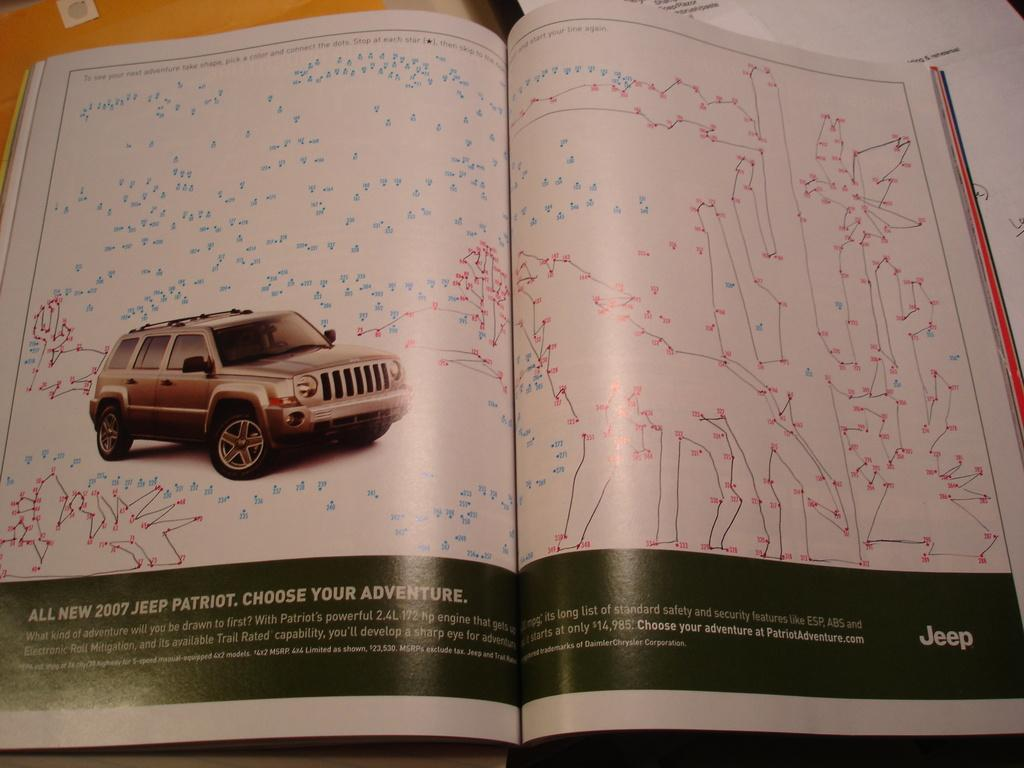What is the main object in the image? There is a book in the image. What is depicted within the book? The book contains an image of a vehicle. Can you describe the vehicle in the image? The vehicle has headlights. What else can be seen in the image besides the book and the vehicle? There is printed text in the image. What type of snake is slithering through the downtown area in the image? There is no snake or downtown area present in the image; it features a book with an image of a vehicle and printed text. 